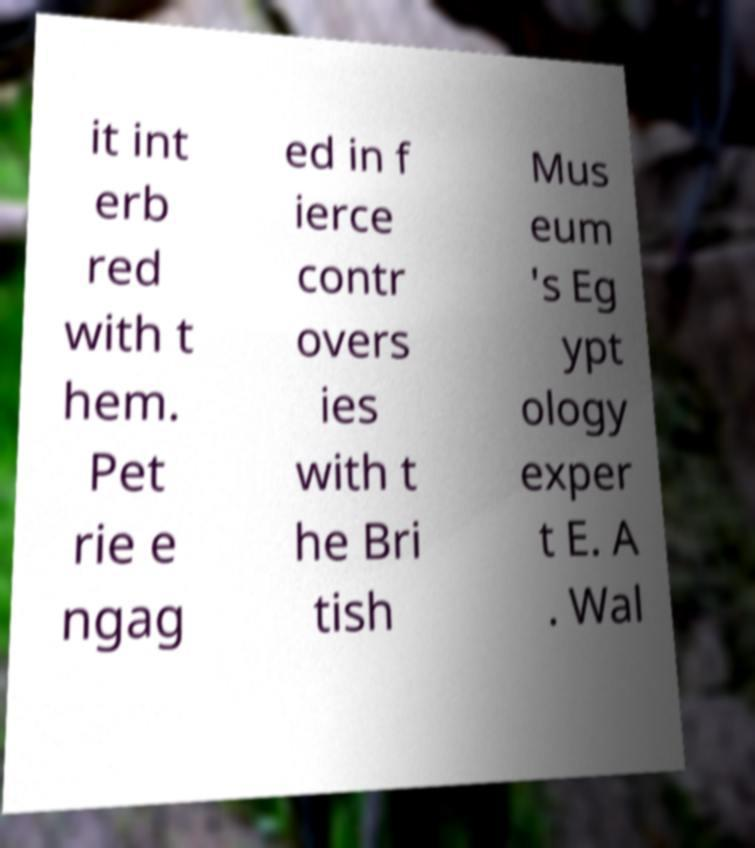Can you read and provide the text displayed in the image?This photo seems to have some interesting text. Can you extract and type it out for me? it int erb red with t hem. Pet rie e ngag ed in f ierce contr overs ies with t he Bri tish Mus eum 's Eg ypt ology exper t E. A . Wal 